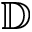<formula> <loc_0><loc_0><loc_500><loc_500>\mathbb { D }</formula> 